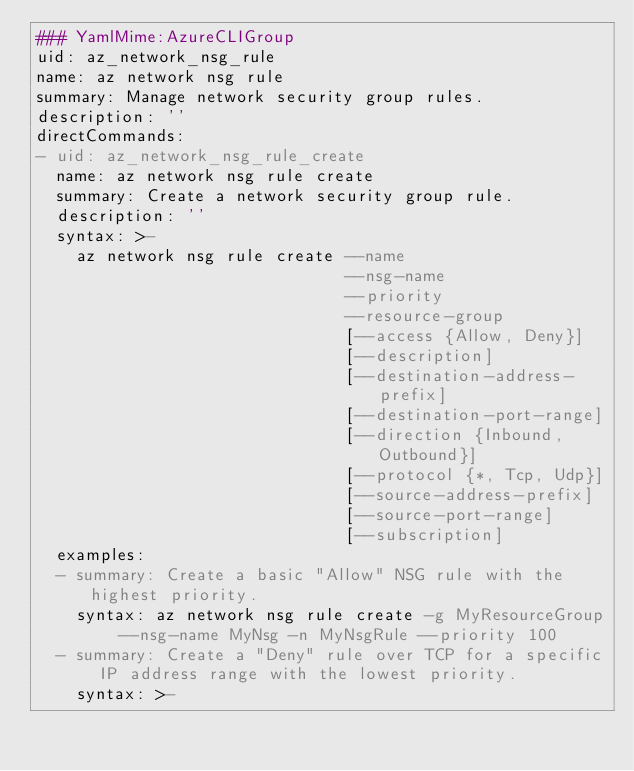Convert code to text. <code><loc_0><loc_0><loc_500><loc_500><_YAML_>### YamlMime:AzureCLIGroup
uid: az_network_nsg_rule
name: az network nsg rule
summary: Manage network security group rules.
description: ''
directCommands:
- uid: az_network_nsg_rule_create
  name: az network nsg rule create
  summary: Create a network security group rule.
  description: ''
  syntax: >-
    az network nsg rule create --name
                               --nsg-name
                               --priority
                               --resource-group
                               [--access {Allow, Deny}]
                               [--description]
                               [--destination-address-prefix]
                               [--destination-port-range]
                               [--direction {Inbound, Outbound}]
                               [--protocol {*, Tcp, Udp}]
                               [--source-address-prefix]
                               [--source-port-range]
                               [--subscription]
  examples:
  - summary: Create a basic "Allow" NSG rule with the highest priority.
    syntax: az network nsg rule create -g MyResourceGroup --nsg-name MyNsg -n MyNsgRule --priority 100
  - summary: Create a "Deny" rule over TCP for a specific IP address range with the lowest priority.
    syntax: >-</code> 